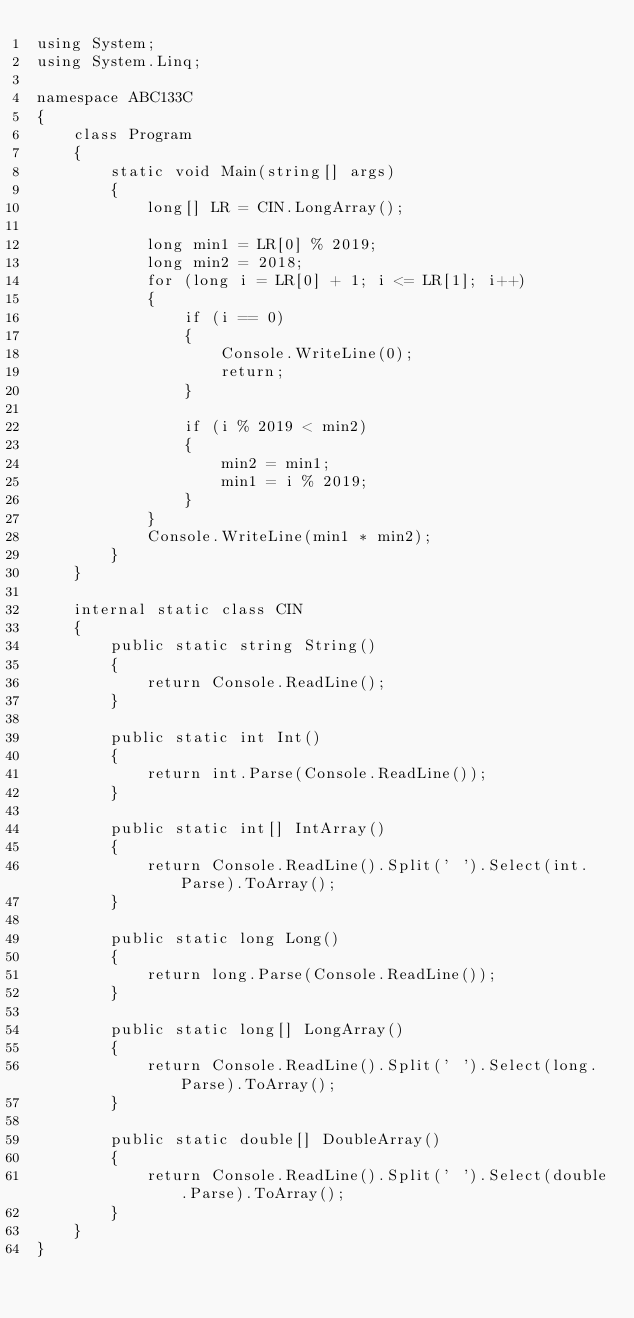<code> <loc_0><loc_0><loc_500><loc_500><_C#_>using System;
using System.Linq;

namespace ABC133C
{
    class Program
    {
        static void Main(string[] args)
        {
            long[] LR = CIN.LongArray();

            long min1 = LR[0] % 2019;
            long min2 = 2018;
            for (long i = LR[0] + 1; i <= LR[1]; i++)
            {
                if (i == 0)
                {
                    Console.WriteLine(0);
                    return;
                }

                if (i % 2019 < min2)
                {
                    min2 = min1;
                    min1 = i % 2019;
                }
            }
            Console.WriteLine(min1 * min2);
        }
    }

    internal static class CIN
    {
        public static string String()
        {
            return Console.ReadLine();
        }

        public static int Int()
        {
            return int.Parse(Console.ReadLine());
        }

        public static int[] IntArray()
        {
            return Console.ReadLine().Split(' ').Select(int.Parse).ToArray();
        }

        public static long Long()
        {
            return long.Parse(Console.ReadLine());
        }

        public static long[] LongArray()
        {
            return Console.ReadLine().Split(' ').Select(long.Parse).ToArray();
        }

        public static double[] DoubleArray()
        {
            return Console.ReadLine().Split(' ').Select(double.Parse).ToArray();
        }
    }
}</code> 